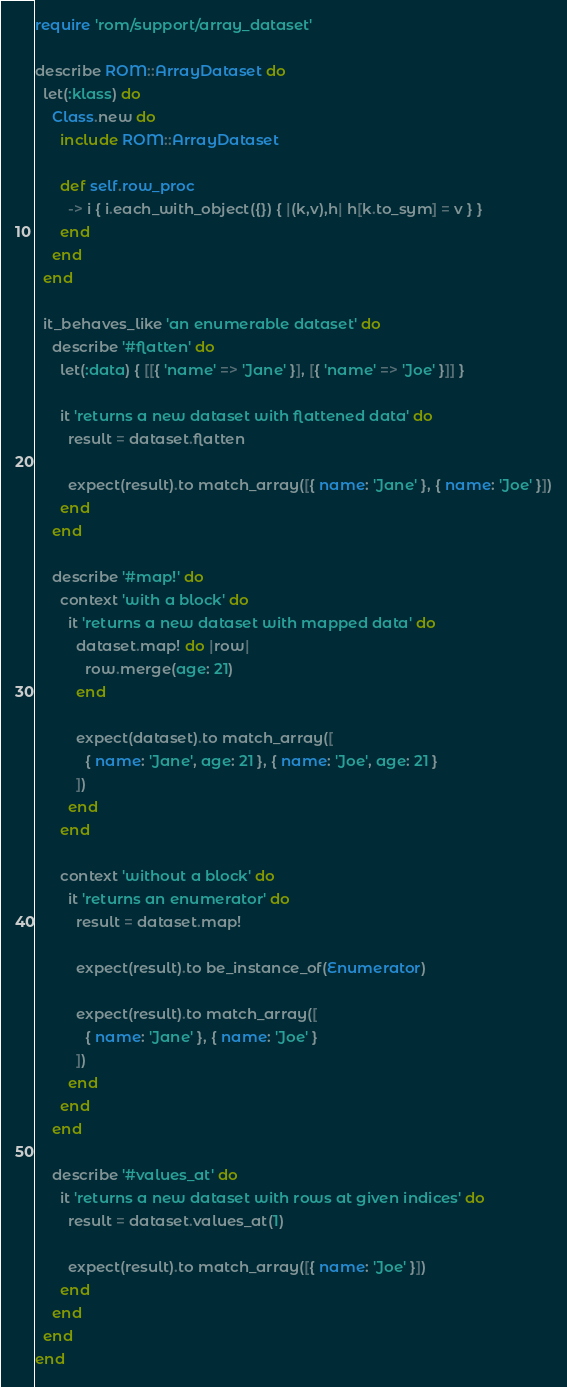Convert code to text. <code><loc_0><loc_0><loc_500><loc_500><_Ruby_>require 'rom/support/array_dataset'

describe ROM::ArrayDataset do
  let(:klass) do
    Class.new do
      include ROM::ArrayDataset

      def self.row_proc
        -> i { i.each_with_object({}) { |(k,v),h| h[k.to_sym] = v } }
      end
    end
  end

  it_behaves_like 'an enumerable dataset' do
    describe '#flatten' do
      let(:data) { [[{ 'name' => 'Jane' }], [{ 'name' => 'Joe' }]] }

      it 'returns a new dataset with flattened data' do
        result = dataset.flatten

        expect(result).to match_array([{ name: 'Jane' }, { name: 'Joe' }])
      end
    end

    describe '#map!' do
      context 'with a block' do
        it 'returns a new dataset with mapped data' do
          dataset.map! do |row|
            row.merge(age: 21)
          end

          expect(dataset).to match_array([
            { name: 'Jane', age: 21 }, { name: 'Joe', age: 21 }
          ])
        end
      end

      context 'without a block' do
        it 'returns an enumerator' do
          result = dataset.map!

          expect(result).to be_instance_of(Enumerator)

          expect(result).to match_array([
            { name: 'Jane' }, { name: 'Joe' }
          ])
        end
      end
    end

    describe '#values_at' do
      it 'returns a new dataset with rows at given indices' do
        result = dataset.values_at(1)

        expect(result).to match_array([{ name: 'Joe' }])
      end
    end
  end
end
</code> 